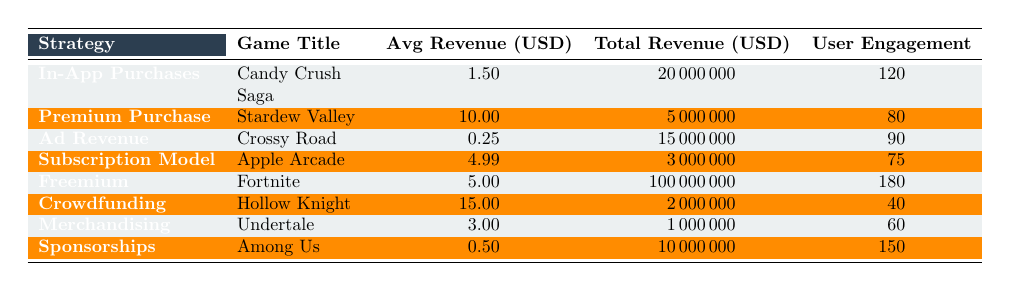What is the total revenue generated by the Freemium strategy? The table lists the total revenue for the Freemium strategy (Fortnite) as 100000000.
Answer: 100000000 Which game under the Premium Purchase strategy has the highest average revenue per user? The table shows that Stardew Valley has an average revenue per user of 10.00, which is higher than any other game listed under the same strategy.
Answer: Stardew Valley What is the user engagement level for crowdfunding games? According to the table, the user engagement level for Hollow Knight (the only listed crowdfunding game) is 40.
Answer: 40 Is the average revenue per user for Sponsorships greater than that for Ad Revenue? The average revenue per user for Sponsorships is 0.50, while for Ad Revenue, it is 0.25. Since 0.50 is greater than 0.25, the statement is true.
Answer: Yes How much more total revenue does Fortnite generate than Hollow Knight? The total revenue for Fortnite is 100000000, and for Hollow Knight, it is 2000000. Subtracting these values gives 100000000 - 2000000 = 98000000, indicating that Fortnite generates 98000000 more in revenue.
Answer: 98000000 What is the average user engagement across all strategies? To find the average, sum all user engagements (120 + 80 + 90 + 75 + 180 + 40 + 60 + 150 = 795) and divide by the total number of strategies (8), resulting in 795 / 8 = 99.375.
Answer: 99.375 Does Candy Crush Saga have a lower average revenue per user compared to Undertale? Candy Crush Saga has an average revenue per user of 1.50, while Undertale has 3.00. Since 1.50 is less than 3.00, the statement is true.
Answer: Yes Which monetization strategy has the lowest average revenue per user? The table shows that Ad Revenue (Crossy Road) has the lowest average revenue per user of 0.25 compared to the other strategies.
Answer: Ad Revenue How much total revenue is generated by games with an engagement level greater than 100? The games with an engagement level greater than 100 are Candy Crush Saga (120), Fortnite (180), and Among Us (150). Their total revenue is 20000000 + 100000000 + 10000000 = 120000000.
Answer: 120000000 